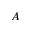Convert formula to latex. <formula><loc_0><loc_0><loc_500><loc_500>A</formula> 